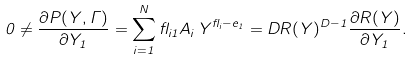Convert formula to latex. <formula><loc_0><loc_0><loc_500><loc_500>0 \neq \frac { \partial P ( { Y } , \Gamma ) } { \partial { Y } _ { 1 } } = \sum _ { i = 1 } ^ { N } \gamma _ { i 1 } A _ { i } \, { Y } ^ { \gamma _ { i } - { e } _ { 1 } } = D R ( { Y } ) ^ { D - 1 } \frac { \partial R ( { Y } ) } { \partial { Y } _ { 1 } } .</formula> 